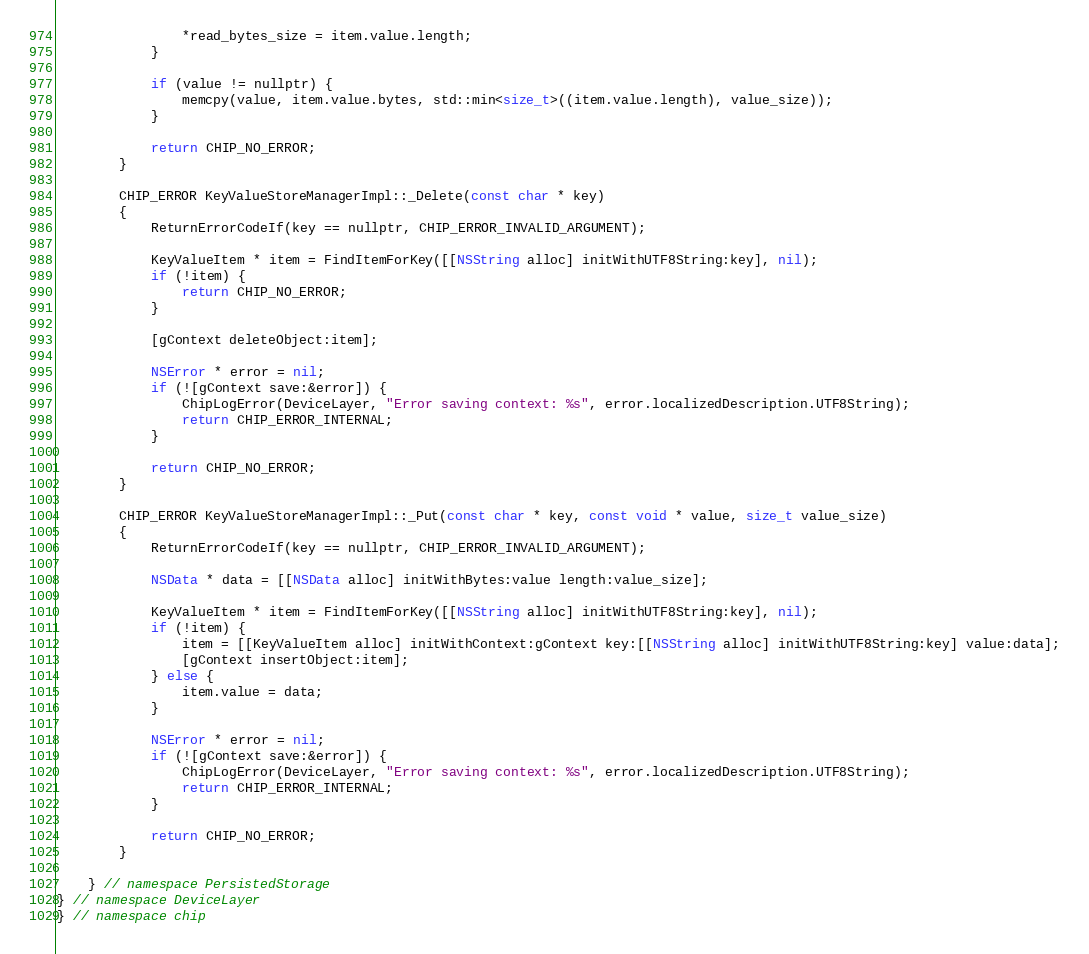<code> <loc_0><loc_0><loc_500><loc_500><_ObjectiveC_>                *read_bytes_size = item.value.length;
            }

            if (value != nullptr) {
                memcpy(value, item.value.bytes, std::min<size_t>((item.value.length), value_size));
            }

            return CHIP_NO_ERROR;
        }

        CHIP_ERROR KeyValueStoreManagerImpl::_Delete(const char * key)
        {
            ReturnErrorCodeIf(key == nullptr, CHIP_ERROR_INVALID_ARGUMENT);

            KeyValueItem * item = FindItemForKey([[NSString alloc] initWithUTF8String:key], nil);
            if (!item) {
                return CHIP_NO_ERROR;
            }

            [gContext deleteObject:item];

            NSError * error = nil;
            if (![gContext save:&error]) {
                ChipLogError(DeviceLayer, "Error saving context: %s", error.localizedDescription.UTF8String);
                return CHIP_ERROR_INTERNAL;
            }

            return CHIP_NO_ERROR;
        }

        CHIP_ERROR KeyValueStoreManagerImpl::_Put(const char * key, const void * value, size_t value_size)
        {
            ReturnErrorCodeIf(key == nullptr, CHIP_ERROR_INVALID_ARGUMENT);

            NSData * data = [[NSData alloc] initWithBytes:value length:value_size];

            KeyValueItem * item = FindItemForKey([[NSString alloc] initWithUTF8String:key], nil);
            if (!item) {
                item = [[KeyValueItem alloc] initWithContext:gContext key:[[NSString alloc] initWithUTF8String:key] value:data];
                [gContext insertObject:item];
            } else {
                item.value = data;
            }

            NSError * error = nil;
            if (![gContext save:&error]) {
                ChipLogError(DeviceLayer, "Error saving context: %s", error.localizedDescription.UTF8String);
                return CHIP_ERROR_INTERNAL;
            }

            return CHIP_NO_ERROR;
        }

    } // namespace PersistedStorage
} // namespace DeviceLayer
} // namespace chip
</code> 